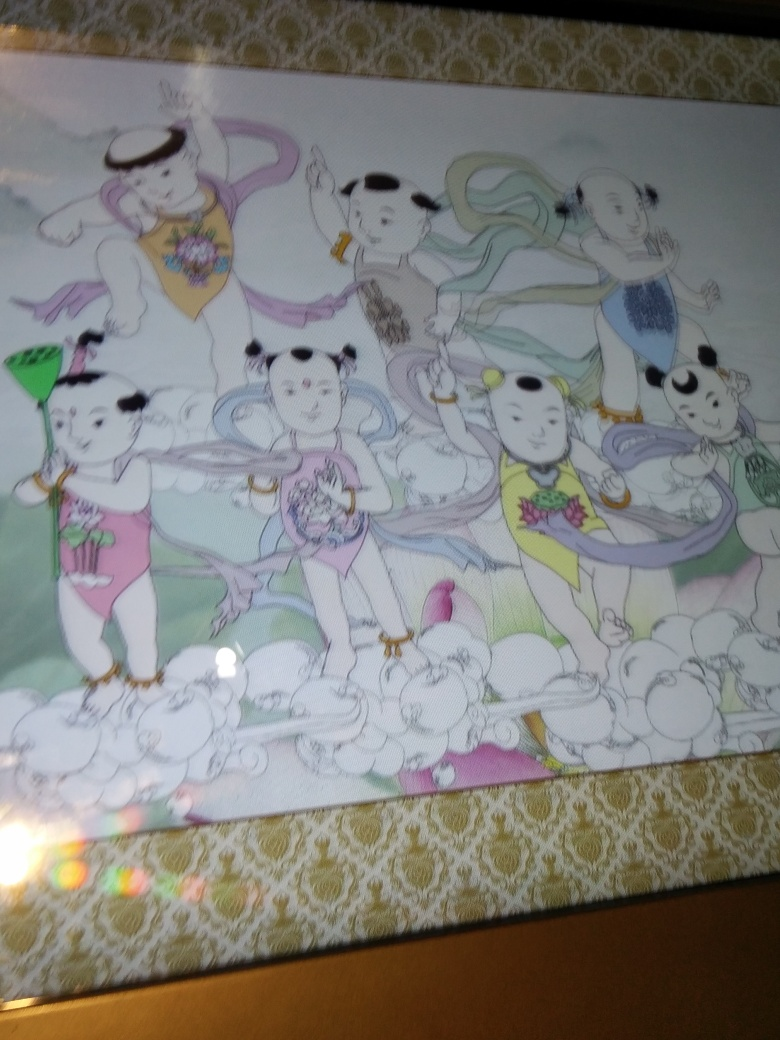What might be a possible narrative depicted in this scene? This image could be depicting a fantasy narrative where panda-like beings are participating in a celebratory procession or festival. Each character's activity, from playing a musical instrument to dancing or holding items like a fan or umbrella, suggests a communal joy. The objects they hold and their expressions might represent different aspects of their culture or virtues such as harmony, joy, and creativity. 